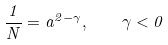Convert formula to latex. <formula><loc_0><loc_0><loc_500><loc_500>\frac { 1 } { N } = a ^ { 2 - \gamma } , \quad \gamma < 0</formula> 